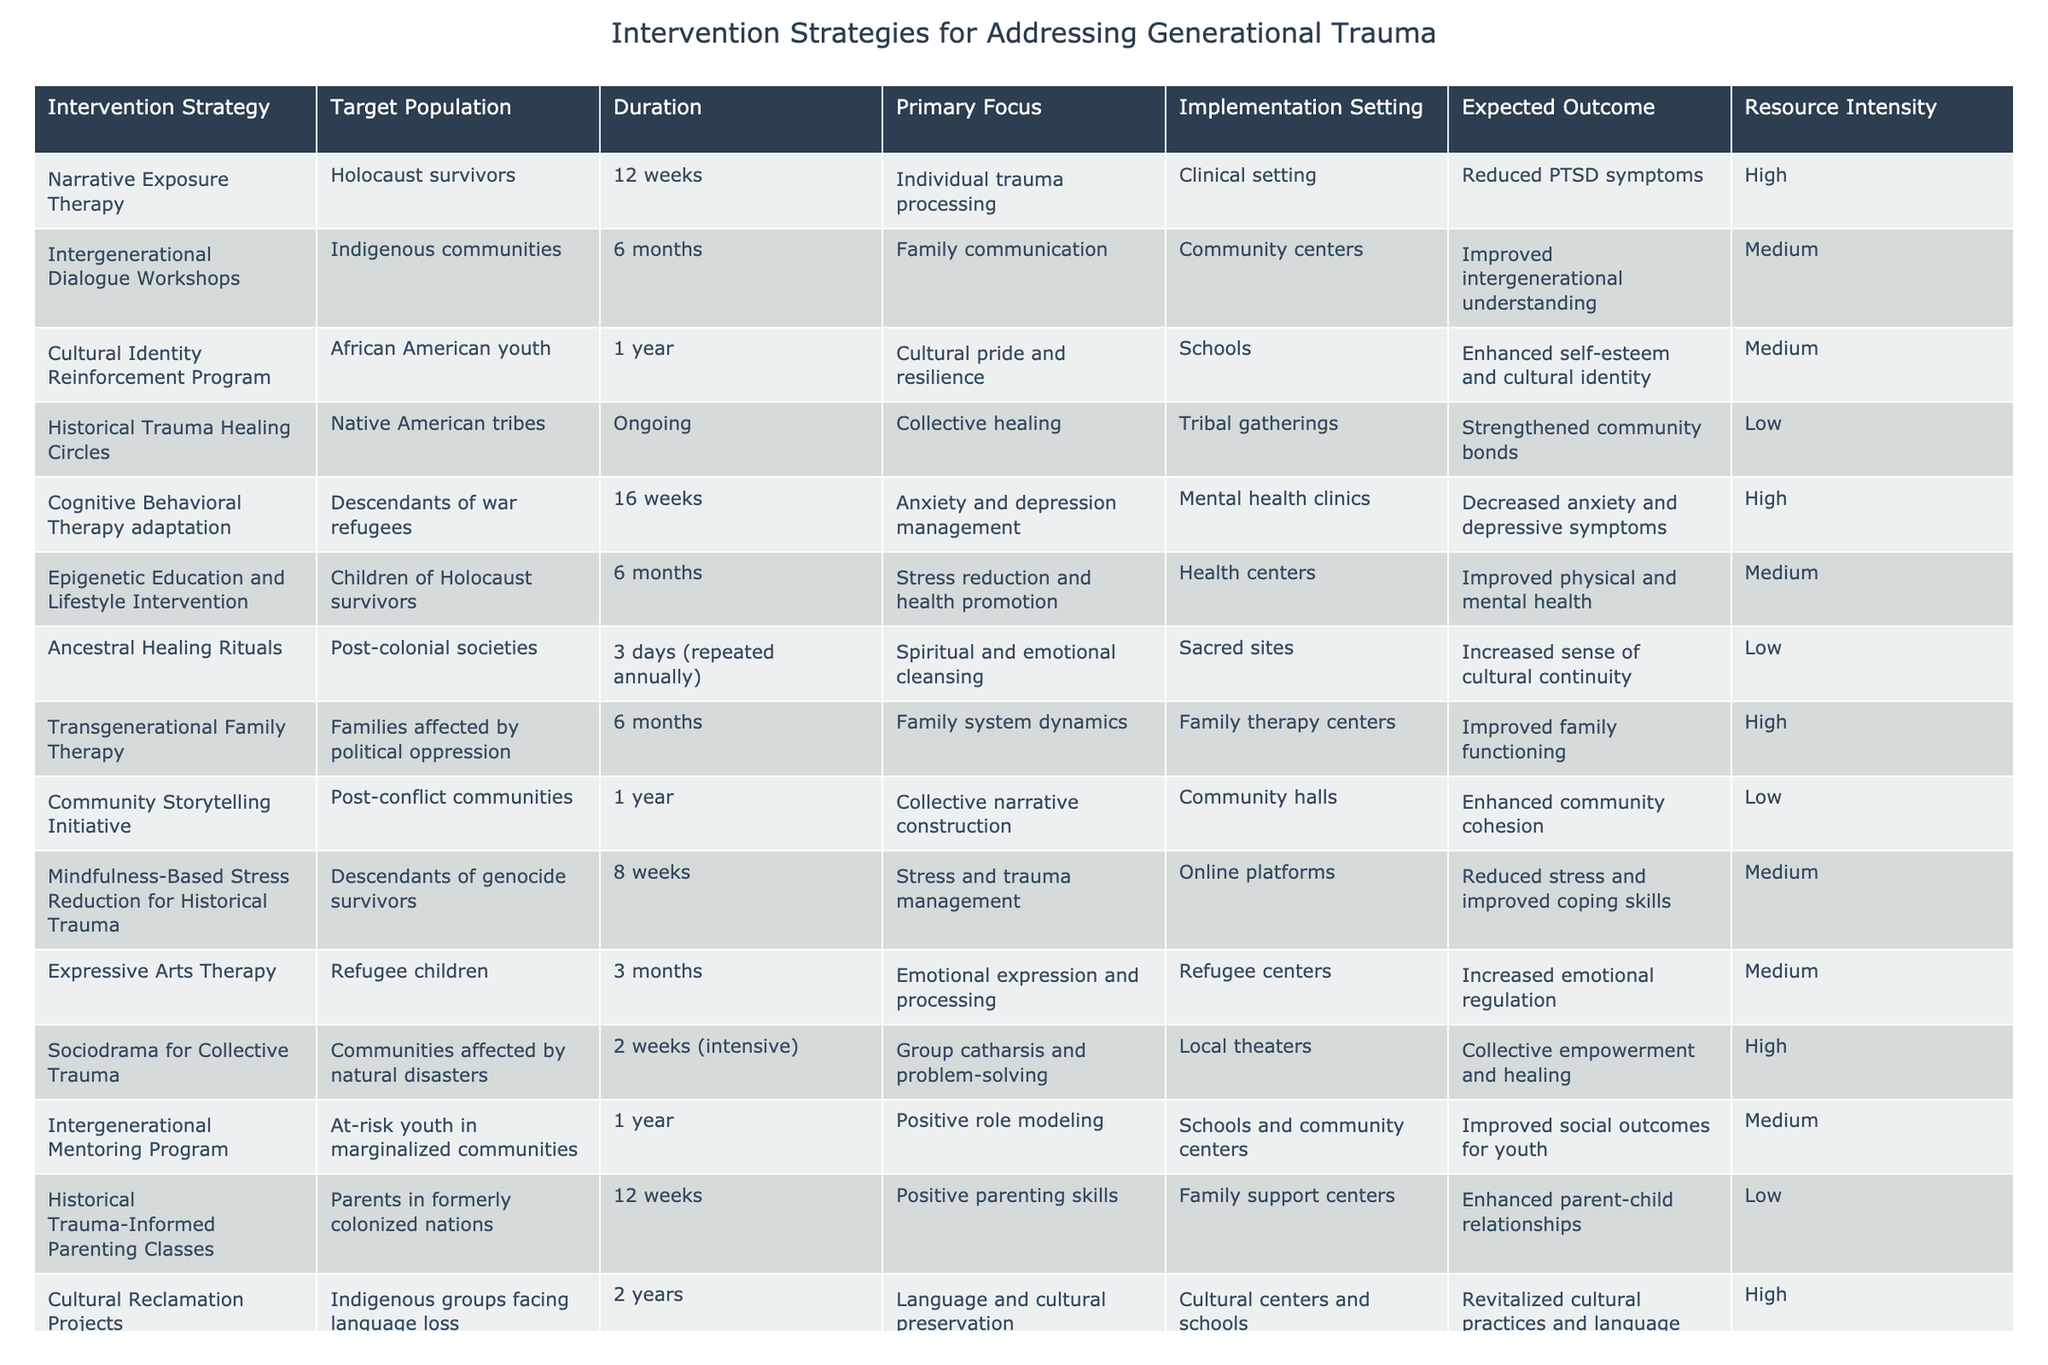What is the expected outcome of the Narrative Exposure Therapy for Holocaust survivors? The table indicates that the expected outcome is "Reduced PTSD symptoms" for the Narrative Exposure Therapy intervention.
Answer: Reduced PTSD symptoms Which intervention strategy has the longest duration? By examining the Duration column, the Cultural Reclamation Projects for Indigenous groups facing language loss has the longest duration at 2 years.
Answer: 2 years Are Historical Trauma Healing Circles resource intensive? The Resource Intensity column shows that Historical Trauma Healing Circles are classified as "Low," indicating that they are not resource intensive.
Answer: No What is the average duration of all intervention strategies listed? To find the average duration, we convert all durations to a uniform unit (weeks): 12, 26 (6 months), 52 (1 year), ongoing (assumed as a large number), 16, 26, 3, 52, 8, 12, 3, 104 (2 years). The sum is approximately 415 weeks divided by 12 strategies results in an average of around 34.58 weeks.
Answer: 34.58 weeks Which intervention strategies focus on individual trauma processing and have high resource intensity? Looking at the table, we find that only Narrative Exposure Therapy fits this description as it has high resource intensity and focuses on individual trauma processing.
Answer: Narrative Exposure Therapy How many intervention strategies are aimed specifically at children? By checking the table, we see that Epigenetic Education and Lifestyle Intervention, and Expressive Arts Therapy are both aimed at children, making it a total of 2 strategies.
Answer: 2 Is there any intervention strategy that addresses collective healing for Native American tribes? Yes, the Historical Trauma Healing Circles specifically target Native American tribes for collective healing.
Answer: Yes Which intervention strategy is expected to enhance self-esteem and cultural identity? Cultural Identity Reinforcement Program is the intervention designed to enhance self-esteem and cultural identity according to the Expected Outcome column.
Answer: Cultural Identity Reinforcement Program 